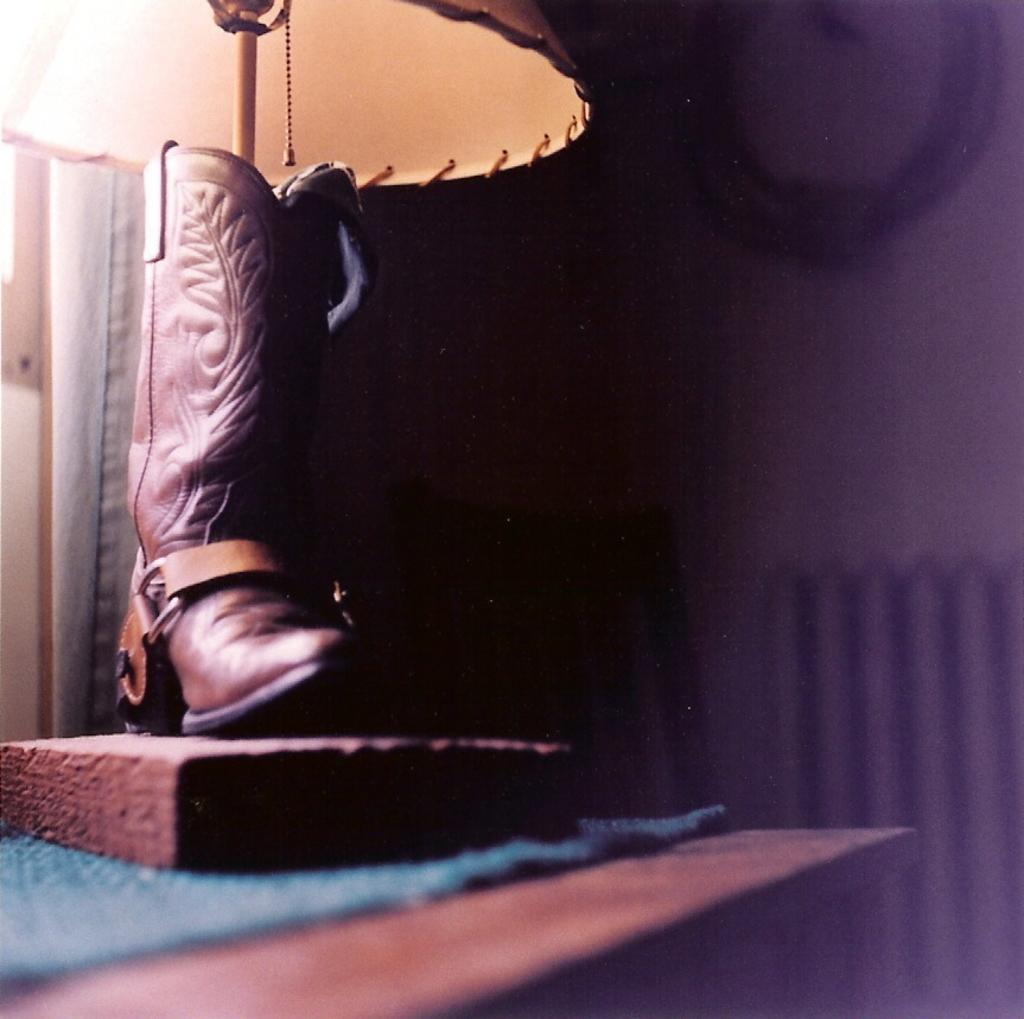What object is located on the left side of the image? There is a boot on the left side of the image. What type of light source is present in the image? There is a lamp in the image. What piece of furniture can be seen in the image? There is a table in the image. What material is present in the image? There is cloth in the image. What surface is used for writing or drawing in the image? There is a board in the image. What architectural feature is visible in the background of the image? There is a wall in the background of the image. What type of window treatment is present in the background of the image? There is a curtain in the background of the image. What opening is present in the wall in the background of the image? There is a window in the background of the image. Where is the sink located in the image? There is no sink present in the image. What type of notebook is visible on the table in the image? There is no notebook present in the image. 